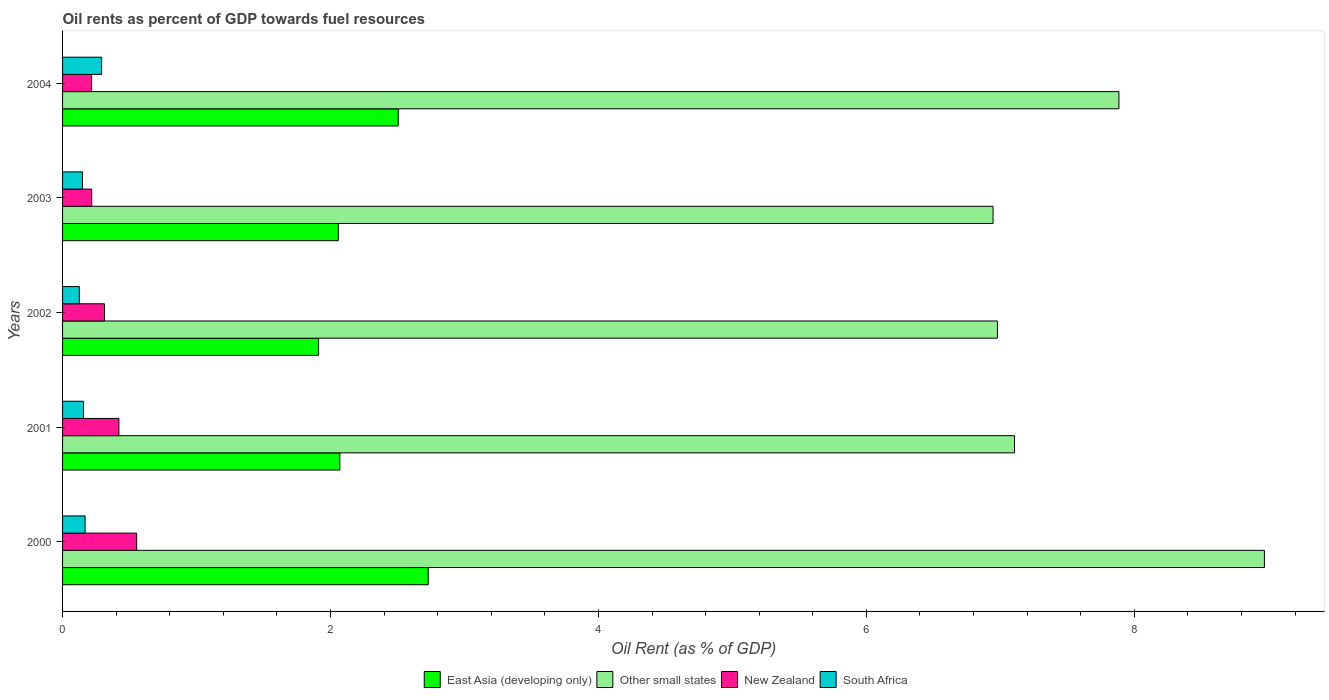How many different coloured bars are there?
Your answer should be very brief. 4. Are the number of bars on each tick of the Y-axis equal?
Keep it short and to the point. Yes. How many bars are there on the 1st tick from the top?
Offer a very short reply. 4. How many bars are there on the 3rd tick from the bottom?
Ensure brevity in your answer.  4. In how many cases, is the number of bars for a given year not equal to the number of legend labels?
Provide a succinct answer. 0. What is the oil rent in Other small states in 2004?
Your answer should be compact. 7.89. Across all years, what is the maximum oil rent in Other small states?
Your response must be concise. 8.97. Across all years, what is the minimum oil rent in East Asia (developing only)?
Give a very brief answer. 1.91. In which year was the oil rent in New Zealand maximum?
Your response must be concise. 2000. In which year was the oil rent in Other small states minimum?
Ensure brevity in your answer.  2003. What is the total oil rent in South Africa in the graph?
Your answer should be compact. 0.89. What is the difference between the oil rent in East Asia (developing only) in 2002 and that in 2003?
Provide a short and direct response. -0.15. What is the difference between the oil rent in South Africa in 2004 and the oil rent in Other small states in 2000?
Make the answer very short. -8.68. What is the average oil rent in Other small states per year?
Ensure brevity in your answer.  7.58. In the year 2002, what is the difference between the oil rent in Other small states and oil rent in New Zealand?
Offer a terse response. 6.67. What is the ratio of the oil rent in East Asia (developing only) in 2001 to that in 2003?
Ensure brevity in your answer.  1.01. Is the oil rent in South Africa in 2000 less than that in 2004?
Ensure brevity in your answer.  Yes. Is the difference between the oil rent in Other small states in 2001 and 2003 greater than the difference between the oil rent in New Zealand in 2001 and 2003?
Give a very brief answer. No. What is the difference between the highest and the second highest oil rent in New Zealand?
Your answer should be very brief. 0.13. What is the difference between the highest and the lowest oil rent in New Zealand?
Your answer should be compact. 0.34. In how many years, is the oil rent in Other small states greater than the average oil rent in Other small states taken over all years?
Provide a succinct answer. 2. What does the 4th bar from the top in 2002 represents?
Make the answer very short. East Asia (developing only). What does the 2nd bar from the bottom in 2000 represents?
Keep it short and to the point. Other small states. How many years are there in the graph?
Give a very brief answer. 5. What is the difference between two consecutive major ticks on the X-axis?
Offer a very short reply. 2. Does the graph contain any zero values?
Provide a succinct answer. No. Does the graph contain grids?
Your response must be concise. No. Where does the legend appear in the graph?
Provide a succinct answer. Bottom center. What is the title of the graph?
Offer a very short reply. Oil rents as percent of GDP towards fuel resources. Does "Denmark" appear as one of the legend labels in the graph?
Offer a terse response. No. What is the label or title of the X-axis?
Ensure brevity in your answer.  Oil Rent (as % of GDP). What is the label or title of the Y-axis?
Provide a succinct answer. Years. What is the Oil Rent (as % of GDP) of East Asia (developing only) in 2000?
Keep it short and to the point. 2.73. What is the Oil Rent (as % of GDP) in Other small states in 2000?
Your answer should be very brief. 8.97. What is the Oil Rent (as % of GDP) of New Zealand in 2000?
Offer a very short reply. 0.55. What is the Oil Rent (as % of GDP) of South Africa in 2000?
Your answer should be very brief. 0.17. What is the Oil Rent (as % of GDP) of East Asia (developing only) in 2001?
Provide a short and direct response. 2.07. What is the Oil Rent (as % of GDP) in Other small states in 2001?
Offer a very short reply. 7.11. What is the Oil Rent (as % of GDP) in New Zealand in 2001?
Provide a short and direct response. 0.42. What is the Oil Rent (as % of GDP) of South Africa in 2001?
Your answer should be very brief. 0.16. What is the Oil Rent (as % of GDP) in East Asia (developing only) in 2002?
Your answer should be very brief. 1.91. What is the Oil Rent (as % of GDP) of Other small states in 2002?
Offer a terse response. 6.98. What is the Oil Rent (as % of GDP) of New Zealand in 2002?
Offer a very short reply. 0.31. What is the Oil Rent (as % of GDP) in South Africa in 2002?
Offer a very short reply. 0.13. What is the Oil Rent (as % of GDP) of East Asia (developing only) in 2003?
Ensure brevity in your answer.  2.06. What is the Oil Rent (as % of GDP) in Other small states in 2003?
Provide a succinct answer. 6.95. What is the Oil Rent (as % of GDP) of New Zealand in 2003?
Keep it short and to the point. 0.22. What is the Oil Rent (as % of GDP) of South Africa in 2003?
Keep it short and to the point. 0.15. What is the Oil Rent (as % of GDP) of East Asia (developing only) in 2004?
Your response must be concise. 2.51. What is the Oil Rent (as % of GDP) in Other small states in 2004?
Provide a succinct answer. 7.89. What is the Oil Rent (as % of GDP) in New Zealand in 2004?
Provide a short and direct response. 0.22. What is the Oil Rent (as % of GDP) in South Africa in 2004?
Keep it short and to the point. 0.29. Across all years, what is the maximum Oil Rent (as % of GDP) in East Asia (developing only)?
Provide a short and direct response. 2.73. Across all years, what is the maximum Oil Rent (as % of GDP) of Other small states?
Your answer should be compact. 8.97. Across all years, what is the maximum Oil Rent (as % of GDP) of New Zealand?
Your response must be concise. 0.55. Across all years, what is the maximum Oil Rent (as % of GDP) of South Africa?
Offer a terse response. 0.29. Across all years, what is the minimum Oil Rent (as % of GDP) in East Asia (developing only)?
Ensure brevity in your answer.  1.91. Across all years, what is the minimum Oil Rent (as % of GDP) in Other small states?
Offer a terse response. 6.95. Across all years, what is the minimum Oil Rent (as % of GDP) of New Zealand?
Your response must be concise. 0.22. Across all years, what is the minimum Oil Rent (as % of GDP) of South Africa?
Provide a succinct answer. 0.13. What is the total Oil Rent (as % of GDP) in East Asia (developing only) in the graph?
Your answer should be very brief. 11.27. What is the total Oil Rent (as % of GDP) of Other small states in the graph?
Make the answer very short. 37.88. What is the total Oil Rent (as % of GDP) in New Zealand in the graph?
Provide a succinct answer. 1.72. What is the total Oil Rent (as % of GDP) of South Africa in the graph?
Give a very brief answer. 0.89. What is the difference between the Oil Rent (as % of GDP) in East Asia (developing only) in 2000 and that in 2001?
Your answer should be compact. 0.66. What is the difference between the Oil Rent (as % of GDP) of Other small states in 2000 and that in 2001?
Your response must be concise. 1.87. What is the difference between the Oil Rent (as % of GDP) in New Zealand in 2000 and that in 2001?
Offer a terse response. 0.13. What is the difference between the Oil Rent (as % of GDP) of South Africa in 2000 and that in 2001?
Keep it short and to the point. 0.01. What is the difference between the Oil Rent (as % of GDP) of East Asia (developing only) in 2000 and that in 2002?
Ensure brevity in your answer.  0.82. What is the difference between the Oil Rent (as % of GDP) of Other small states in 2000 and that in 2002?
Your response must be concise. 1.99. What is the difference between the Oil Rent (as % of GDP) of New Zealand in 2000 and that in 2002?
Offer a terse response. 0.24. What is the difference between the Oil Rent (as % of GDP) of South Africa in 2000 and that in 2002?
Provide a succinct answer. 0.04. What is the difference between the Oil Rent (as % of GDP) of East Asia (developing only) in 2000 and that in 2003?
Provide a short and direct response. 0.67. What is the difference between the Oil Rent (as % of GDP) of Other small states in 2000 and that in 2003?
Your answer should be very brief. 2.03. What is the difference between the Oil Rent (as % of GDP) of New Zealand in 2000 and that in 2003?
Provide a short and direct response. 0.34. What is the difference between the Oil Rent (as % of GDP) of South Africa in 2000 and that in 2003?
Your answer should be very brief. 0.02. What is the difference between the Oil Rent (as % of GDP) of East Asia (developing only) in 2000 and that in 2004?
Make the answer very short. 0.22. What is the difference between the Oil Rent (as % of GDP) in Other small states in 2000 and that in 2004?
Offer a terse response. 1.09. What is the difference between the Oil Rent (as % of GDP) in New Zealand in 2000 and that in 2004?
Your answer should be compact. 0.34. What is the difference between the Oil Rent (as % of GDP) in South Africa in 2000 and that in 2004?
Provide a short and direct response. -0.12. What is the difference between the Oil Rent (as % of GDP) in East Asia (developing only) in 2001 and that in 2002?
Provide a short and direct response. 0.16. What is the difference between the Oil Rent (as % of GDP) in Other small states in 2001 and that in 2002?
Provide a succinct answer. 0.13. What is the difference between the Oil Rent (as % of GDP) in New Zealand in 2001 and that in 2002?
Offer a terse response. 0.11. What is the difference between the Oil Rent (as % of GDP) of South Africa in 2001 and that in 2002?
Provide a succinct answer. 0.03. What is the difference between the Oil Rent (as % of GDP) of East Asia (developing only) in 2001 and that in 2003?
Offer a terse response. 0.01. What is the difference between the Oil Rent (as % of GDP) in Other small states in 2001 and that in 2003?
Keep it short and to the point. 0.16. What is the difference between the Oil Rent (as % of GDP) of New Zealand in 2001 and that in 2003?
Your response must be concise. 0.2. What is the difference between the Oil Rent (as % of GDP) of South Africa in 2001 and that in 2003?
Provide a succinct answer. 0.01. What is the difference between the Oil Rent (as % of GDP) in East Asia (developing only) in 2001 and that in 2004?
Offer a very short reply. -0.44. What is the difference between the Oil Rent (as % of GDP) in Other small states in 2001 and that in 2004?
Ensure brevity in your answer.  -0.78. What is the difference between the Oil Rent (as % of GDP) in New Zealand in 2001 and that in 2004?
Give a very brief answer. 0.2. What is the difference between the Oil Rent (as % of GDP) in South Africa in 2001 and that in 2004?
Ensure brevity in your answer.  -0.14. What is the difference between the Oil Rent (as % of GDP) of East Asia (developing only) in 2002 and that in 2003?
Offer a very short reply. -0.15. What is the difference between the Oil Rent (as % of GDP) in Other small states in 2002 and that in 2003?
Make the answer very short. 0.03. What is the difference between the Oil Rent (as % of GDP) in New Zealand in 2002 and that in 2003?
Offer a very short reply. 0.1. What is the difference between the Oil Rent (as % of GDP) of South Africa in 2002 and that in 2003?
Make the answer very short. -0.02. What is the difference between the Oil Rent (as % of GDP) of East Asia (developing only) in 2002 and that in 2004?
Your answer should be compact. -0.59. What is the difference between the Oil Rent (as % of GDP) in Other small states in 2002 and that in 2004?
Give a very brief answer. -0.91. What is the difference between the Oil Rent (as % of GDP) in New Zealand in 2002 and that in 2004?
Ensure brevity in your answer.  0.1. What is the difference between the Oil Rent (as % of GDP) in South Africa in 2002 and that in 2004?
Offer a terse response. -0.17. What is the difference between the Oil Rent (as % of GDP) in East Asia (developing only) in 2003 and that in 2004?
Offer a very short reply. -0.45. What is the difference between the Oil Rent (as % of GDP) of Other small states in 2003 and that in 2004?
Keep it short and to the point. -0.94. What is the difference between the Oil Rent (as % of GDP) in New Zealand in 2003 and that in 2004?
Provide a succinct answer. 0. What is the difference between the Oil Rent (as % of GDP) of South Africa in 2003 and that in 2004?
Ensure brevity in your answer.  -0.14. What is the difference between the Oil Rent (as % of GDP) of East Asia (developing only) in 2000 and the Oil Rent (as % of GDP) of Other small states in 2001?
Keep it short and to the point. -4.38. What is the difference between the Oil Rent (as % of GDP) of East Asia (developing only) in 2000 and the Oil Rent (as % of GDP) of New Zealand in 2001?
Keep it short and to the point. 2.31. What is the difference between the Oil Rent (as % of GDP) in East Asia (developing only) in 2000 and the Oil Rent (as % of GDP) in South Africa in 2001?
Provide a short and direct response. 2.57. What is the difference between the Oil Rent (as % of GDP) of Other small states in 2000 and the Oil Rent (as % of GDP) of New Zealand in 2001?
Provide a short and direct response. 8.55. What is the difference between the Oil Rent (as % of GDP) of Other small states in 2000 and the Oil Rent (as % of GDP) of South Africa in 2001?
Offer a terse response. 8.81. What is the difference between the Oil Rent (as % of GDP) of New Zealand in 2000 and the Oil Rent (as % of GDP) of South Africa in 2001?
Your answer should be compact. 0.4. What is the difference between the Oil Rent (as % of GDP) of East Asia (developing only) in 2000 and the Oil Rent (as % of GDP) of Other small states in 2002?
Make the answer very short. -4.25. What is the difference between the Oil Rent (as % of GDP) of East Asia (developing only) in 2000 and the Oil Rent (as % of GDP) of New Zealand in 2002?
Give a very brief answer. 2.42. What is the difference between the Oil Rent (as % of GDP) in East Asia (developing only) in 2000 and the Oil Rent (as % of GDP) in South Africa in 2002?
Provide a short and direct response. 2.6. What is the difference between the Oil Rent (as % of GDP) of Other small states in 2000 and the Oil Rent (as % of GDP) of New Zealand in 2002?
Ensure brevity in your answer.  8.66. What is the difference between the Oil Rent (as % of GDP) of Other small states in 2000 and the Oil Rent (as % of GDP) of South Africa in 2002?
Give a very brief answer. 8.85. What is the difference between the Oil Rent (as % of GDP) in New Zealand in 2000 and the Oil Rent (as % of GDP) in South Africa in 2002?
Your response must be concise. 0.43. What is the difference between the Oil Rent (as % of GDP) in East Asia (developing only) in 2000 and the Oil Rent (as % of GDP) in Other small states in 2003?
Keep it short and to the point. -4.22. What is the difference between the Oil Rent (as % of GDP) in East Asia (developing only) in 2000 and the Oil Rent (as % of GDP) in New Zealand in 2003?
Make the answer very short. 2.51. What is the difference between the Oil Rent (as % of GDP) of East Asia (developing only) in 2000 and the Oil Rent (as % of GDP) of South Africa in 2003?
Provide a short and direct response. 2.58. What is the difference between the Oil Rent (as % of GDP) in Other small states in 2000 and the Oil Rent (as % of GDP) in New Zealand in 2003?
Keep it short and to the point. 8.75. What is the difference between the Oil Rent (as % of GDP) of Other small states in 2000 and the Oil Rent (as % of GDP) of South Africa in 2003?
Make the answer very short. 8.82. What is the difference between the Oil Rent (as % of GDP) of New Zealand in 2000 and the Oil Rent (as % of GDP) of South Africa in 2003?
Provide a succinct answer. 0.4. What is the difference between the Oil Rent (as % of GDP) in East Asia (developing only) in 2000 and the Oil Rent (as % of GDP) in Other small states in 2004?
Your response must be concise. -5.16. What is the difference between the Oil Rent (as % of GDP) of East Asia (developing only) in 2000 and the Oil Rent (as % of GDP) of New Zealand in 2004?
Offer a terse response. 2.51. What is the difference between the Oil Rent (as % of GDP) of East Asia (developing only) in 2000 and the Oil Rent (as % of GDP) of South Africa in 2004?
Give a very brief answer. 2.44. What is the difference between the Oil Rent (as % of GDP) of Other small states in 2000 and the Oil Rent (as % of GDP) of New Zealand in 2004?
Your response must be concise. 8.75. What is the difference between the Oil Rent (as % of GDP) in Other small states in 2000 and the Oil Rent (as % of GDP) in South Africa in 2004?
Your answer should be compact. 8.68. What is the difference between the Oil Rent (as % of GDP) in New Zealand in 2000 and the Oil Rent (as % of GDP) in South Africa in 2004?
Offer a terse response. 0.26. What is the difference between the Oil Rent (as % of GDP) of East Asia (developing only) in 2001 and the Oil Rent (as % of GDP) of Other small states in 2002?
Offer a very short reply. -4.91. What is the difference between the Oil Rent (as % of GDP) in East Asia (developing only) in 2001 and the Oil Rent (as % of GDP) in New Zealand in 2002?
Your answer should be compact. 1.76. What is the difference between the Oil Rent (as % of GDP) of East Asia (developing only) in 2001 and the Oil Rent (as % of GDP) of South Africa in 2002?
Offer a very short reply. 1.94. What is the difference between the Oil Rent (as % of GDP) in Other small states in 2001 and the Oil Rent (as % of GDP) in New Zealand in 2002?
Make the answer very short. 6.79. What is the difference between the Oil Rent (as % of GDP) in Other small states in 2001 and the Oil Rent (as % of GDP) in South Africa in 2002?
Your answer should be compact. 6.98. What is the difference between the Oil Rent (as % of GDP) of New Zealand in 2001 and the Oil Rent (as % of GDP) of South Africa in 2002?
Keep it short and to the point. 0.3. What is the difference between the Oil Rent (as % of GDP) in East Asia (developing only) in 2001 and the Oil Rent (as % of GDP) in Other small states in 2003?
Your answer should be compact. -4.88. What is the difference between the Oil Rent (as % of GDP) in East Asia (developing only) in 2001 and the Oil Rent (as % of GDP) in New Zealand in 2003?
Provide a succinct answer. 1.85. What is the difference between the Oil Rent (as % of GDP) of East Asia (developing only) in 2001 and the Oil Rent (as % of GDP) of South Africa in 2003?
Provide a short and direct response. 1.92. What is the difference between the Oil Rent (as % of GDP) of Other small states in 2001 and the Oil Rent (as % of GDP) of New Zealand in 2003?
Provide a succinct answer. 6.89. What is the difference between the Oil Rent (as % of GDP) of Other small states in 2001 and the Oil Rent (as % of GDP) of South Africa in 2003?
Ensure brevity in your answer.  6.96. What is the difference between the Oil Rent (as % of GDP) in New Zealand in 2001 and the Oil Rent (as % of GDP) in South Africa in 2003?
Your response must be concise. 0.27. What is the difference between the Oil Rent (as % of GDP) of East Asia (developing only) in 2001 and the Oil Rent (as % of GDP) of Other small states in 2004?
Provide a short and direct response. -5.82. What is the difference between the Oil Rent (as % of GDP) in East Asia (developing only) in 2001 and the Oil Rent (as % of GDP) in New Zealand in 2004?
Make the answer very short. 1.85. What is the difference between the Oil Rent (as % of GDP) in East Asia (developing only) in 2001 and the Oil Rent (as % of GDP) in South Africa in 2004?
Provide a succinct answer. 1.78. What is the difference between the Oil Rent (as % of GDP) of Other small states in 2001 and the Oil Rent (as % of GDP) of New Zealand in 2004?
Your answer should be very brief. 6.89. What is the difference between the Oil Rent (as % of GDP) of Other small states in 2001 and the Oil Rent (as % of GDP) of South Africa in 2004?
Your answer should be compact. 6.81. What is the difference between the Oil Rent (as % of GDP) of New Zealand in 2001 and the Oil Rent (as % of GDP) of South Africa in 2004?
Give a very brief answer. 0.13. What is the difference between the Oil Rent (as % of GDP) in East Asia (developing only) in 2002 and the Oil Rent (as % of GDP) in Other small states in 2003?
Keep it short and to the point. -5.03. What is the difference between the Oil Rent (as % of GDP) of East Asia (developing only) in 2002 and the Oil Rent (as % of GDP) of New Zealand in 2003?
Make the answer very short. 1.69. What is the difference between the Oil Rent (as % of GDP) of East Asia (developing only) in 2002 and the Oil Rent (as % of GDP) of South Africa in 2003?
Your answer should be very brief. 1.76. What is the difference between the Oil Rent (as % of GDP) of Other small states in 2002 and the Oil Rent (as % of GDP) of New Zealand in 2003?
Ensure brevity in your answer.  6.76. What is the difference between the Oil Rent (as % of GDP) in Other small states in 2002 and the Oil Rent (as % of GDP) in South Africa in 2003?
Provide a short and direct response. 6.83. What is the difference between the Oil Rent (as % of GDP) in New Zealand in 2002 and the Oil Rent (as % of GDP) in South Africa in 2003?
Keep it short and to the point. 0.16. What is the difference between the Oil Rent (as % of GDP) in East Asia (developing only) in 2002 and the Oil Rent (as % of GDP) in Other small states in 2004?
Ensure brevity in your answer.  -5.97. What is the difference between the Oil Rent (as % of GDP) of East Asia (developing only) in 2002 and the Oil Rent (as % of GDP) of New Zealand in 2004?
Offer a very short reply. 1.69. What is the difference between the Oil Rent (as % of GDP) of East Asia (developing only) in 2002 and the Oil Rent (as % of GDP) of South Africa in 2004?
Give a very brief answer. 1.62. What is the difference between the Oil Rent (as % of GDP) of Other small states in 2002 and the Oil Rent (as % of GDP) of New Zealand in 2004?
Make the answer very short. 6.76. What is the difference between the Oil Rent (as % of GDP) in Other small states in 2002 and the Oil Rent (as % of GDP) in South Africa in 2004?
Make the answer very short. 6.69. What is the difference between the Oil Rent (as % of GDP) of New Zealand in 2002 and the Oil Rent (as % of GDP) of South Africa in 2004?
Your answer should be very brief. 0.02. What is the difference between the Oil Rent (as % of GDP) of East Asia (developing only) in 2003 and the Oil Rent (as % of GDP) of Other small states in 2004?
Your answer should be compact. -5.83. What is the difference between the Oil Rent (as % of GDP) of East Asia (developing only) in 2003 and the Oil Rent (as % of GDP) of New Zealand in 2004?
Offer a very short reply. 1.84. What is the difference between the Oil Rent (as % of GDP) of East Asia (developing only) in 2003 and the Oil Rent (as % of GDP) of South Africa in 2004?
Offer a very short reply. 1.77. What is the difference between the Oil Rent (as % of GDP) in Other small states in 2003 and the Oil Rent (as % of GDP) in New Zealand in 2004?
Provide a succinct answer. 6.73. What is the difference between the Oil Rent (as % of GDP) in Other small states in 2003 and the Oil Rent (as % of GDP) in South Africa in 2004?
Offer a very short reply. 6.65. What is the difference between the Oil Rent (as % of GDP) of New Zealand in 2003 and the Oil Rent (as % of GDP) of South Africa in 2004?
Offer a terse response. -0.07. What is the average Oil Rent (as % of GDP) of East Asia (developing only) per year?
Offer a terse response. 2.25. What is the average Oil Rent (as % of GDP) in Other small states per year?
Your answer should be very brief. 7.58. What is the average Oil Rent (as % of GDP) of New Zealand per year?
Offer a very short reply. 0.34. What is the average Oil Rent (as % of GDP) in South Africa per year?
Your answer should be very brief. 0.18. In the year 2000, what is the difference between the Oil Rent (as % of GDP) of East Asia (developing only) and Oil Rent (as % of GDP) of Other small states?
Your answer should be very brief. -6.24. In the year 2000, what is the difference between the Oil Rent (as % of GDP) of East Asia (developing only) and Oil Rent (as % of GDP) of New Zealand?
Your response must be concise. 2.18. In the year 2000, what is the difference between the Oil Rent (as % of GDP) in East Asia (developing only) and Oil Rent (as % of GDP) in South Africa?
Your answer should be very brief. 2.56. In the year 2000, what is the difference between the Oil Rent (as % of GDP) in Other small states and Oil Rent (as % of GDP) in New Zealand?
Provide a succinct answer. 8.42. In the year 2000, what is the difference between the Oil Rent (as % of GDP) of Other small states and Oil Rent (as % of GDP) of South Africa?
Keep it short and to the point. 8.8. In the year 2000, what is the difference between the Oil Rent (as % of GDP) of New Zealand and Oil Rent (as % of GDP) of South Africa?
Keep it short and to the point. 0.39. In the year 2001, what is the difference between the Oil Rent (as % of GDP) in East Asia (developing only) and Oil Rent (as % of GDP) in Other small states?
Provide a succinct answer. -5.04. In the year 2001, what is the difference between the Oil Rent (as % of GDP) of East Asia (developing only) and Oil Rent (as % of GDP) of New Zealand?
Give a very brief answer. 1.65. In the year 2001, what is the difference between the Oil Rent (as % of GDP) in East Asia (developing only) and Oil Rent (as % of GDP) in South Africa?
Ensure brevity in your answer.  1.91. In the year 2001, what is the difference between the Oil Rent (as % of GDP) in Other small states and Oil Rent (as % of GDP) in New Zealand?
Provide a short and direct response. 6.69. In the year 2001, what is the difference between the Oil Rent (as % of GDP) in Other small states and Oil Rent (as % of GDP) in South Africa?
Ensure brevity in your answer.  6.95. In the year 2001, what is the difference between the Oil Rent (as % of GDP) in New Zealand and Oil Rent (as % of GDP) in South Africa?
Give a very brief answer. 0.26. In the year 2002, what is the difference between the Oil Rent (as % of GDP) of East Asia (developing only) and Oil Rent (as % of GDP) of Other small states?
Offer a very short reply. -5.07. In the year 2002, what is the difference between the Oil Rent (as % of GDP) in East Asia (developing only) and Oil Rent (as % of GDP) in New Zealand?
Offer a terse response. 1.6. In the year 2002, what is the difference between the Oil Rent (as % of GDP) of East Asia (developing only) and Oil Rent (as % of GDP) of South Africa?
Offer a terse response. 1.79. In the year 2002, what is the difference between the Oil Rent (as % of GDP) in Other small states and Oil Rent (as % of GDP) in New Zealand?
Ensure brevity in your answer.  6.67. In the year 2002, what is the difference between the Oil Rent (as % of GDP) in Other small states and Oil Rent (as % of GDP) in South Africa?
Offer a very short reply. 6.85. In the year 2002, what is the difference between the Oil Rent (as % of GDP) in New Zealand and Oil Rent (as % of GDP) in South Africa?
Keep it short and to the point. 0.19. In the year 2003, what is the difference between the Oil Rent (as % of GDP) in East Asia (developing only) and Oil Rent (as % of GDP) in Other small states?
Make the answer very short. -4.89. In the year 2003, what is the difference between the Oil Rent (as % of GDP) in East Asia (developing only) and Oil Rent (as % of GDP) in New Zealand?
Offer a very short reply. 1.84. In the year 2003, what is the difference between the Oil Rent (as % of GDP) in East Asia (developing only) and Oil Rent (as % of GDP) in South Africa?
Your answer should be very brief. 1.91. In the year 2003, what is the difference between the Oil Rent (as % of GDP) of Other small states and Oil Rent (as % of GDP) of New Zealand?
Provide a succinct answer. 6.73. In the year 2003, what is the difference between the Oil Rent (as % of GDP) of Other small states and Oil Rent (as % of GDP) of South Africa?
Keep it short and to the point. 6.8. In the year 2003, what is the difference between the Oil Rent (as % of GDP) in New Zealand and Oil Rent (as % of GDP) in South Africa?
Ensure brevity in your answer.  0.07. In the year 2004, what is the difference between the Oil Rent (as % of GDP) of East Asia (developing only) and Oil Rent (as % of GDP) of Other small states?
Give a very brief answer. -5.38. In the year 2004, what is the difference between the Oil Rent (as % of GDP) of East Asia (developing only) and Oil Rent (as % of GDP) of New Zealand?
Your answer should be compact. 2.29. In the year 2004, what is the difference between the Oil Rent (as % of GDP) in East Asia (developing only) and Oil Rent (as % of GDP) in South Africa?
Your response must be concise. 2.21. In the year 2004, what is the difference between the Oil Rent (as % of GDP) of Other small states and Oil Rent (as % of GDP) of New Zealand?
Your answer should be very brief. 7.67. In the year 2004, what is the difference between the Oil Rent (as % of GDP) in Other small states and Oil Rent (as % of GDP) in South Africa?
Keep it short and to the point. 7.59. In the year 2004, what is the difference between the Oil Rent (as % of GDP) in New Zealand and Oil Rent (as % of GDP) in South Africa?
Make the answer very short. -0.08. What is the ratio of the Oil Rent (as % of GDP) in East Asia (developing only) in 2000 to that in 2001?
Ensure brevity in your answer.  1.32. What is the ratio of the Oil Rent (as % of GDP) of Other small states in 2000 to that in 2001?
Make the answer very short. 1.26. What is the ratio of the Oil Rent (as % of GDP) of New Zealand in 2000 to that in 2001?
Your answer should be very brief. 1.32. What is the ratio of the Oil Rent (as % of GDP) in South Africa in 2000 to that in 2001?
Offer a terse response. 1.07. What is the ratio of the Oil Rent (as % of GDP) of East Asia (developing only) in 2000 to that in 2002?
Your answer should be very brief. 1.43. What is the ratio of the Oil Rent (as % of GDP) of Other small states in 2000 to that in 2002?
Your answer should be very brief. 1.29. What is the ratio of the Oil Rent (as % of GDP) in New Zealand in 2000 to that in 2002?
Give a very brief answer. 1.77. What is the ratio of the Oil Rent (as % of GDP) of South Africa in 2000 to that in 2002?
Your answer should be compact. 1.34. What is the ratio of the Oil Rent (as % of GDP) in East Asia (developing only) in 2000 to that in 2003?
Keep it short and to the point. 1.33. What is the ratio of the Oil Rent (as % of GDP) in Other small states in 2000 to that in 2003?
Provide a short and direct response. 1.29. What is the ratio of the Oil Rent (as % of GDP) in New Zealand in 2000 to that in 2003?
Offer a very short reply. 2.54. What is the ratio of the Oil Rent (as % of GDP) of South Africa in 2000 to that in 2003?
Your response must be concise. 1.13. What is the ratio of the Oil Rent (as % of GDP) of East Asia (developing only) in 2000 to that in 2004?
Your answer should be compact. 1.09. What is the ratio of the Oil Rent (as % of GDP) of Other small states in 2000 to that in 2004?
Offer a very short reply. 1.14. What is the ratio of the Oil Rent (as % of GDP) of New Zealand in 2000 to that in 2004?
Give a very brief answer. 2.56. What is the ratio of the Oil Rent (as % of GDP) in South Africa in 2000 to that in 2004?
Give a very brief answer. 0.58. What is the ratio of the Oil Rent (as % of GDP) of East Asia (developing only) in 2001 to that in 2002?
Your response must be concise. 1.08. What is the ratio of the Oil Rent (as % of GDP) of Other small states in 2001 to that in 2002?
Ensure brevity in your answer.  1.02. What is the ratio of the Oil Rent (as % of GDP) in New Zealand in 2001 to that in 2002?
Ensure brevity in your answer.  1.34. What is the ratio of the Oil Rent (as % of GDP) in South Africa in 2001 to that in 2002?
Ensure brevity in your answer.  1.25. What is the ratio of the Oil Rent (as % of GDP) in East Asia (developing only) in 2001 to that in 2003?
Offer a very short reply. 1.01. What is the ratio of the Oil Rent (as % of GDP) of Other small states in 2001 to that in 2003?
Keep it short and to the point. 1.02. What is the ratio of the Oil Rent (as % of GDP) of New Zealand in 2001 to that in 2003?
Provide a short and direct response. 1.93. What is the ratio of the Oil Rent (as % of GDP) of South Africa in 2001 to that in 2003?
Give a very brief answer. 1.05. What is the ratio of the Oil Rent (as % of GDP) of East Asia (developing only) in 2001 to that in 2004?
Your response must be concise. 0.83. What is the ratio of the Oil Rent (as % of GDP) of Other small states in 2001 to that in 2004?
Your response must be concise. 0.9. What is the ratio of the Oil Rent (as % of GDP) of New Zealand in 2001 to that in 2004?
Your answer should be very brief. 1.94. What is the ratio of the Oil Rent (as % of GDP) in South Africa in 2001 to that in 2004?
Keep it short and to the point. 0.54. What is the ratio of the Oil Rent (as % of GDP) in East Asia (developing only) in 2002 to that in 2003?
Provide a short and direct response. 0.93. What is the ratio of the Oil Rent (as % of GDP) of Other small states in 2002 to that in 2003?
Your answer should be compact. 1. What is the ratio of the Oil Rent (as % of GDP) of New Zealand in 2002 to that in 2003?
Your answer should be very brief. 1.44. What is the ratio of the Oil Rent (as % of GDP) in South Africa in 2002 to that in 2003?
Offer a very short reply. 0.84. What is the ratio of the Oil Rent (as % of GDP) of East Asia (developing only) in 2002 to that in 2004?
Make the answer very short. 0.76. What is the ratio of the Oil Rent (as % of GDP) of Other small states in 2002 to that in 2004?
Ensure brevity in your answer.  0.89. What is the ratio of the Oil Rent (as % of GDP) of New Zealand in 2002 to that in 2004?
Give a very brief answer. 1.45. What is the ratio of the Oil Rent (as % of GDP) of South Africa in 2002 to that in 2004?
Your answer should be compact. 0.43. What is the ratio of the Oil Rent (as % of GDP) in East Asia (developing only) in 2003 to that in 2004?
Ensure brevity in your answer.  0.82. What is the ratio of the Oil Rent (as % of GDP) in Other small states in 2003 to that in 2004?
Give a very brief answer. 0.88. What is the ratio of the Oil Rent (as % of GDP) of South Africa in 2003 to that in 2004?
Offer a terse response. 0.51. What is the difference between the highest and the second highest Oil Rent (as % of GDP) of East Asia (developing only)?
Give a very brief answer. 0.22. What is the difference between the highest and the second highest Oil Rent (as % of GDP) in Other small states?
Your answer should be very brief. 1.09. What is the difference between the highest and the second highest Oil Rent (as % of GDP) of New Zealand?
Make the answer very short. 0.13. What is the difference between the highest and the second highest Oil Rent (as % of GDP) of South Africa?
Make the answer very short. 0.12. What is the difference between the highest and the lowest Oil Rent (as % of GDP) of East Asia (developing only)?
Provide a succinct answer. 0.82. What is the difference between the highest and the lowest Oil Rent (as % of GDP) in Other small states?
Your answer should be very brief. 2.03. What is the difference between the highest and the lowest Oil Rent (as % of GDP) in New Zealand?
Keep it short and to the point. 0.34. 